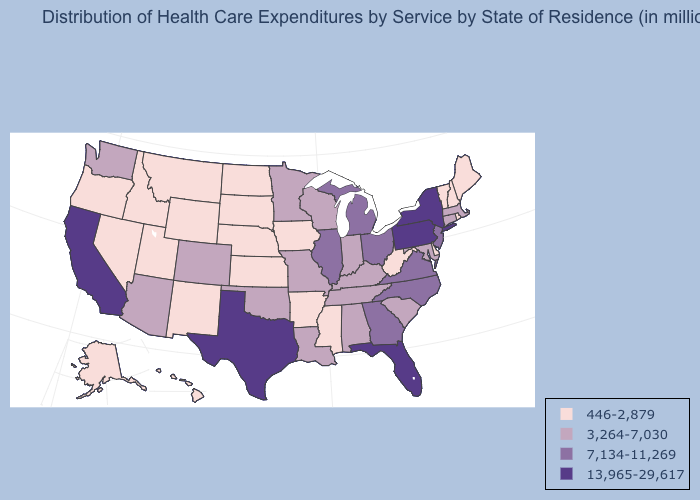Which states have the lowest value in the MidWest?
Concise answer only. Iowa, Kansas, Nebraska, North Dakota, South Dakota. Which states have the lowest value in the USA?
Concise answer only. Alaska, Arkansas, Delaware, Hawaii, Idaho, Iowa, Kansas, Maine, Mississippi, Montana, Nebraska, Nevada, New Hampshire, New Mexico, North Dakota, Oregon, Rhode Island, South Dakota, Utah, Vermont, West Virginia, Wyoming. Does the map have missing data?
Be succinct. No. Name the states that have a value in the range 13,965-29,617?
Give a very brief answer. California, Florida, New York, Pennsylvania, Texas. Which states have the lowest value in the USA?
Quick response, please. Alaska, Arkansas, Delaware, Hawaii, Idaho, Iowa, Kansas, Maine, Mississippi, Montana, Nebraska, Nevada, New Hampshire, New Mexico, North Dakota, Oregon, Rhode Island, South Dakota, Utah, Vermont, West Virginia, Wyoming. Which states have the highest value in the USA?
Answer briefly. California, Florida, New York, Pennsylvania, Texas. Name the states that have a value in the range 13,965-29,617?
Quick response, please. California, Florida, New York, Pennsylvania, Texas. Among the states that border Montana , which have the lowest value?
Short answer required. Idaho, North Dakota, South Dakota, Wyoming. Among the states that border Vermont , which have the lowest value?
Give a very brief answer. New Hampshire. What is the value of Michigan?
Concise answer only. 7,134-11,269. What is the value of California?
Concise answer only. 13,965-29,617. Name the states that have a value in the range 13,965-29,617?
Answer briefly. California, Florida, New York, Pennsylvania, Texas. Name the states that have a value in the range 13,965-29,617?
Quick response, please. California, Florida, New York, Pennsylvania, Texas. Does New York have the highest value in the Northeast?
Quick response, please. Yes. 